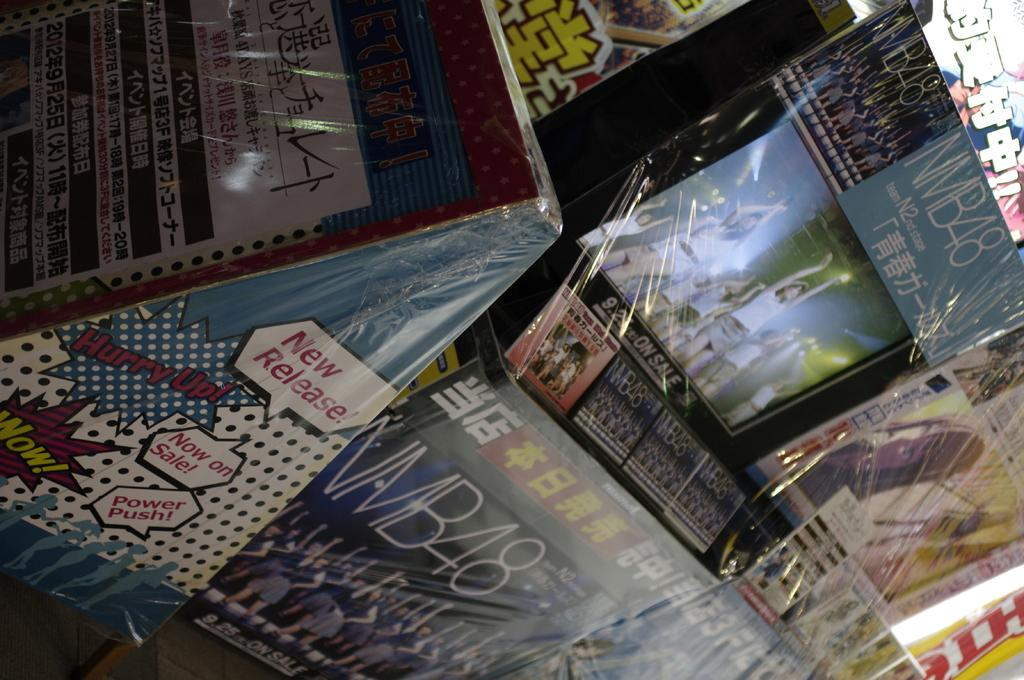<image>
Describe the image concisely. A group of products that are in a plastic casing, and the one at the bottom left has writing claiming it to be a new release. 